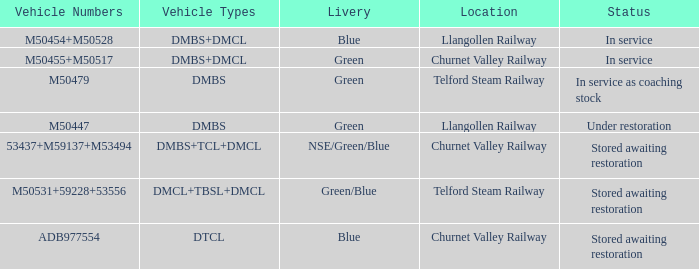What is the condition of the vehicle with the number adb977554? Stored awaiting restoration. Would you mind parsing the complete table? {'header': ['Vehicle Numbers', 'Vehicle Types', 'Livery', 'Location', 'Status'], 'rows': [['M50454+M50528', 'DMBS+DMCL', 'Blue', 'Llangollen Railway', 'In service'], ['M50455+M50517', 'DMBS+DMCL', 'Green', 'Churnet Valley Railway', 'In service'], ['M50479', 'DMBS', 'Green', 'Telford Steam Railway', 'In service as coaching stock'], ['M50447', 'DMBS', 'Green', 'Llangollen Railway', 'Under restoration'], ['53437+M59137+M53494', 'DMBS+TCL+DMCL', 'NSE/Green/Blue', 'Churnet Valley Railway', 'Stored awaiting restoration'], ['M50531+59228+53556', 'DMCL+TBSL+DMCL', 'Green/Blue', 'Telford Steam Railway', 'Stored awaiting restoration'], ['ADB977554', 'DTCL', 'Blue', 'Churnet Valley Railway', 'Stored awaiting restoration']]} 